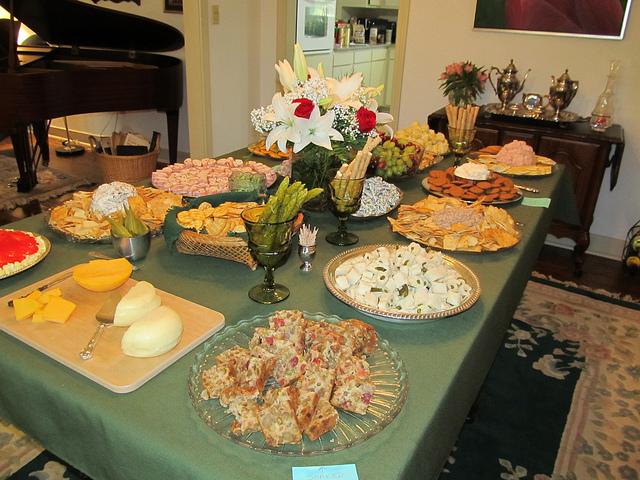Which one has marshmallows on it?
Write a very short answer. 0. What instrument is in the background of the picture?
Give a very brief answer. Piano. Is this for a party?
Answer briefly. Yes. What color are the flowers?
Give a very brief answer. White and red. What is in the middle of the table?
Quick response, please. Flowers. Do you see two rolls of tape in the picture?
Answer briefly. No. 